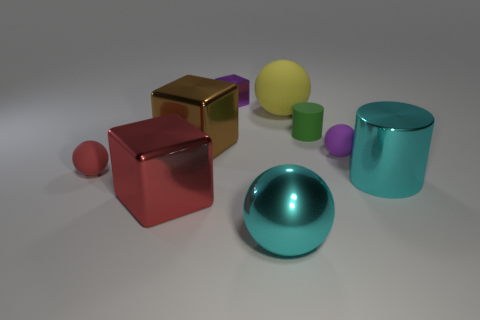Add 1 blue cylinders. How many objects exist? 10 Subtract all cylinders. How many objects are left? 7 Add 4 small matte objects. How many small matte objects are left? 7 Add 6 tiny purple things. How many tiny purple things exist? 8 Subtract 1 purple cubes. How many objects are left? 8 Subtract all matte things. Subtract all large yellow balls. How many objects are left? 4 